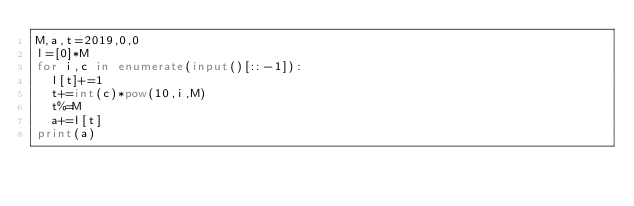<code> <loc_0><loc_0><loc_500><loc_500><_Python_>M,a,t=2019,0,0
l=[0]*M
for i,c in enumerate(input()[::-1]):
  l[t]+=1
  t+=int(c)*pow(10,i,M)
  t%=M
  a+=l[t]
print(a)</code> 